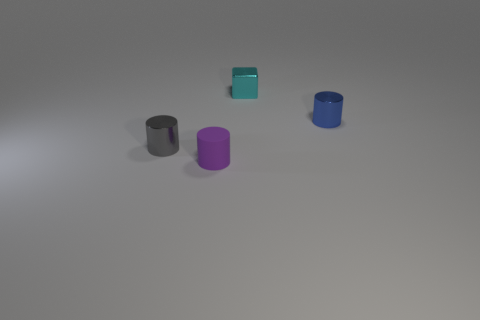Are these objects arranged in a specific order for a reason? It's not entirely clear from the image alone, but it's possible that their arrangement is intentional, either to create a visually pleasing composition, convey an idea through their positioning, or maybe to demonstrate variations in size and color for a display. Could these objects represent any concept? Indeed, the objects might represent concepts like progression or diversity. The varying heights and colors could symbolize growth or change, and their cylindrical shape suggests uniformity amidst these differences. 